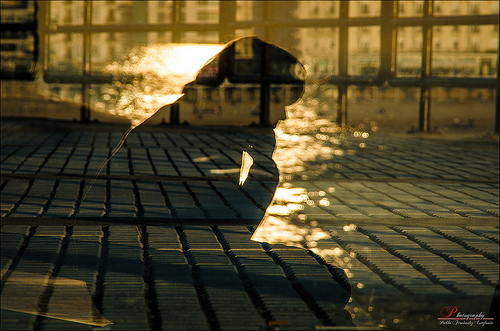<image>
Is there a woman behind the window? No. The woman is not behind the window. From this viewpoint, the woman appears to be positioned elsewhere in the scene. 